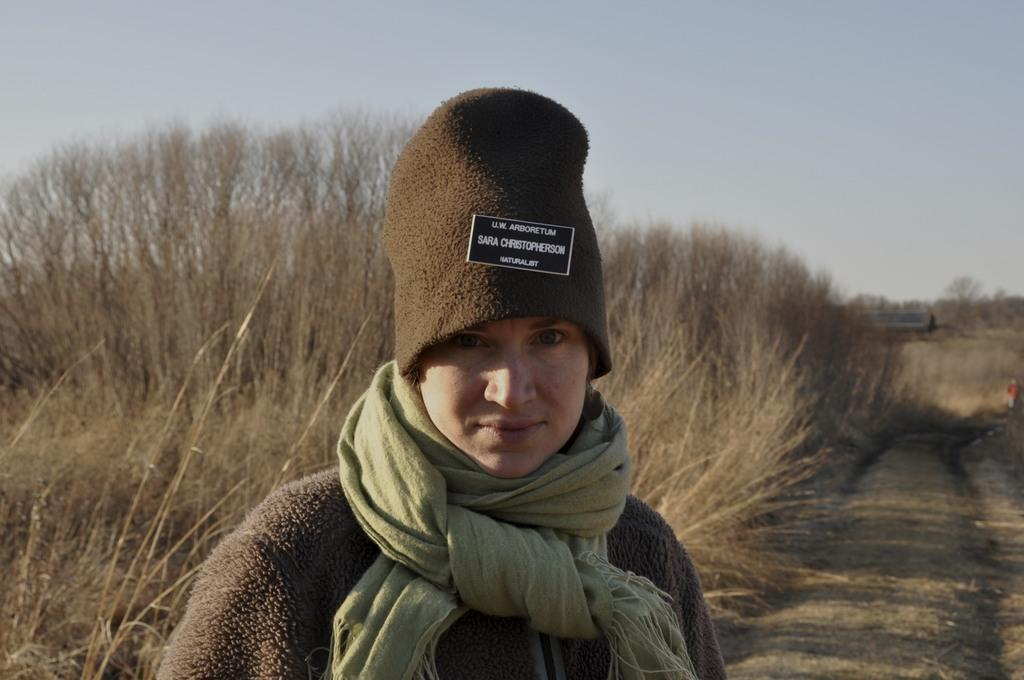Who or what is the main subject in the image? There is a person in the image. What accessories is the person wearing? The person is wearing a scarf and a cap. What can be seen in the background of the image? The sky is visible in the background of the image. What type of celery is being used as a prop in the image? There is no celery present in the image. 